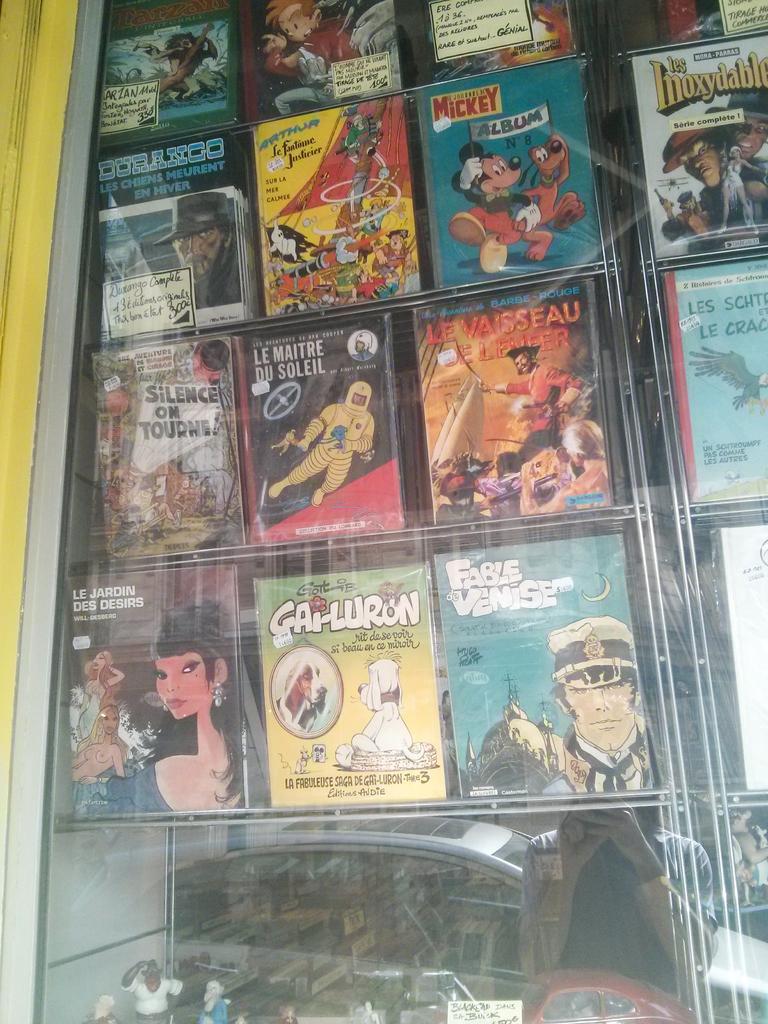Can you describe this image briefly? In this image we can see books arranged in the racks and the reflections of woman standing and a motor vehicle on the road in the mirror. 